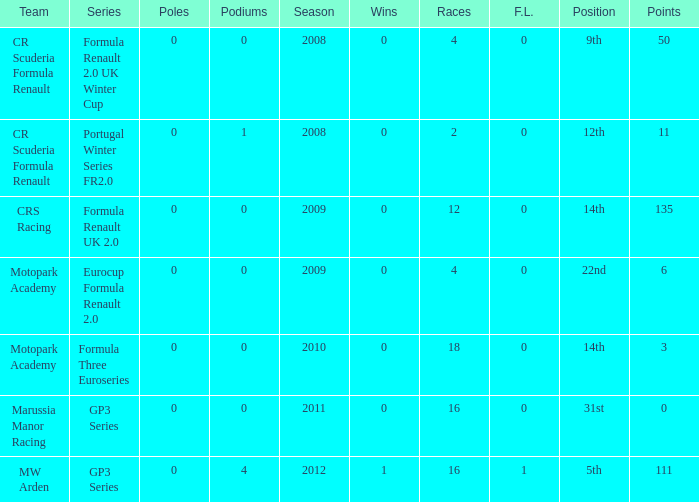What are the most poles listed? 0.0. 